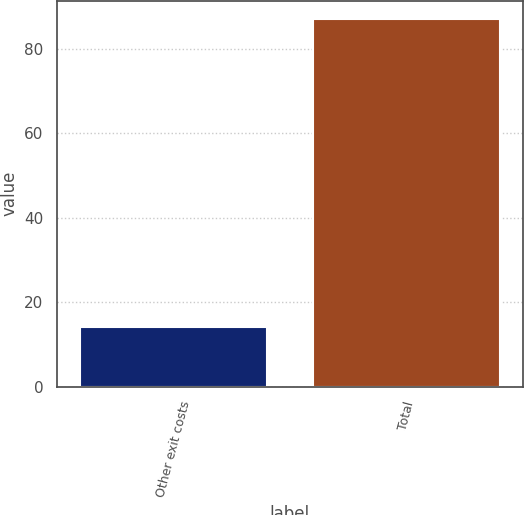<chart> <loc_0><loc_0><loc_500><loc_500><bar_chart><fcel>Other exit costs<fcel>Total<nl><fcel>14<fcel>87<nl></chart> 